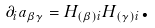<formula> <loc_0><loc_0><loc_500><loc_500>\partial _ { i } a _ { \beta \gamma } = H _ { ( \beta ) i } H _ { ( \gamma ) i } \text {.}</formula> 